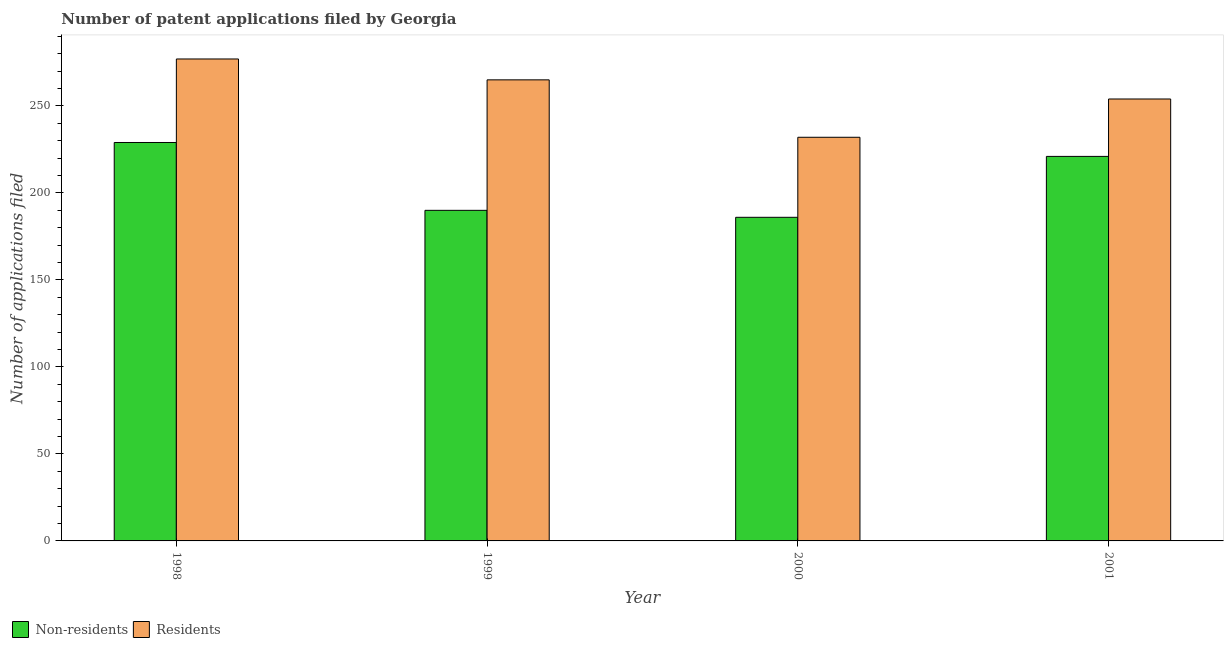How many different coloured bars are there?
Offer a terse response. 2. Are the number of bars per tick equal to the number of legend labels?
Your answer should be very brief. Yes. What is the number of patent applications by residents in 1998?
Your response must be concise. 277. Across all years, what is the maximum number of patent applications by residents?
Your answer should be compact. 277. Across all years, what is the minimum number of patent applications by residents?
Offer a terse response. 232. What is the total number of patent applications by residents in the graph?
Offer a terse response. 1028. What is the difference between the number of patent applications by residents in 1999 and that in 2001?
Provide a short and direct response. 11. What is the difference between the number of patent applications by residents in 1999 and the number of patent applications by non residents in 1998?
Make the answer very short. -12. What is the average number of patent applications by non residents per year?
Offer a very short reply. 206.5. In the year 2001, what is the difference between the number of patent applications by residents and number of patent applications by non residents?
Give a very brief answer. 0. In how many years, is the number of patent applications by non residents greater than 170?
Your response must be concise. 4. What is the ratio of the number of patent applications by non residents in 2000 to that in 2001?
Your response must be concise. 0.84. Is the number of patent applications by residents in 1998 less than that in 2001?
Provide a short and direct response. No. Is the difference between the number of patent applications by non residents in 1998 and 2001 greater than the difference between the number of patent applications by residents in 1998 and 2001?
Keep it short and to the point. No. What is the difference between the highest and the lowest number of patent applications by residents?
Give a very brief answer. 45. What does the 1st bar from the left in 2000 represents?
Your answer should be very brief. Non-residents. What does the 2nd bar from the right in 2000 represents?
Provide a succinct answer. Non-residents. How many years are there in the graph?
Offer a terse response. 4. What is the difference between two consecutive major ticks on the Y-axis?
Your answer should be very brief. 50. Are the values on the major ticks of Y-axis written in scientific E-notation?
Keep it short and to the point. No. Where does the legend appear in the graph?
Your response must be concise. Bottom left. How many legend labels are there?
Keep it short and to the point. 2. What is the title of the graph?
Give a very brief answer. Number of patent applications filed by Georgia. Does "Study and work" appear as one of the legend labels in the graph?
Your response must be concise. No. What is the label or title of the X-axis?
Offer a terse response. Year. What is the label or title of the Y-axis?
Provide a short and direct response. Number of applications filed. What is the Number of applications filed in Non-residents in 1998?
Keep it short and to the point. 229. What is the Number of applications filed of Residents in 1998?
Your response must be concise. 277. What is the Number of applications filed in Non-residents in 1999?
Offer a terse response. 190. What is the Number of applications filed of Residents in 1999?
Give a very brief answer. 265. What is the Number of applications filed in Non-residents in 2000?
Your answer should be very brief. 186. What is the Number of applications filed of Residents in 2000?
Make the answer very short. 232. What is the Number of applications filed of Non-residents in 2001?
Keep it short and to the point. 221. What is the Number of applications filed of Residents in 2001?
Offer a very short reply. 254. Across all years, what is the maximum Number of applications filed in Non-residents?
Your answer should be very brief. 229. Across all years, what is the maximum Number of applications filed of Residents?
Provide a succinct answer. 277. Across all years, what is the minimum Number of applications filed in Non-residents?
Your response must be concise. 186. Across all years, what is the minimum Number of applications filed of Residents?
Provide a short and direct response. 232. What is the total Number of applications filed of Non-residents in the graph?
Make the answer very short. 826. What is the total Number of applications filed of Residents in the graph?
Ensure brevity in your answer.  1028. What is the difference between the Number of applications filed of Residents in 1998 and that in 1999?
Offer a very short reply. 12. What is the difference between the Number of applications filed in Non-residents in 1998 and that in 2000?
Your response must be concise. 43. What is the difference between the Number of applications filed in Non-residents in 1999 and that in 2000?
Offer a terse response. 4. What is the difference between the Number of applications filed in Non-residents in 1999 and that in 2001?
Your answer should be compact. -31. What is the difference between the Number of applications filed in Residents in 1999 and that in 2001?
Offer a terse response. 11. What is the difference between the Number of applications filed of Non-residents in 2000 and that in 2001?
Your answer should be compact. -35. What is the difference between the Number of applications filed in Residents in 2000 and that in 2001?
Give a very brief answer. -22. What is the difference between the Number of applications filed in Non-residents in 1998 and the Number of applications filed in Residents in 1999?
Offer a very short reply. -36. What is the difference between the Number of applications filed in Non-residents in 1998 and the Number of applications filed in Residents in 2000?
Ensure brevity in your answer.  -3. What is the difference between the Number of applications filed in Non-residents in 1999 and the Number of applications filed in Residents in 2000?
Keep it short and to the point. -42. What is the difference between the Number of applications filed in Non-residents in 1999 and the Number of applications filed in Residents in 2001?
Give a very brief answer. -64. What is the difference between the Number of applications filed of Non-residents in 2000 and the Number of applications filed of Residents in 2001?
Give a very brief answer. -68. What is the average Number of applications filed of Non-residents per year?
Offer a very short reply. 206.5. What is the average Number of applications filed in Residents per year?
Make the answer very short. 257. In the year 1998, what is the difference between the Number of applications filed in Non-residents and Number of applications filed in Residents?
Your response must be concise. -48. In the year 1999, what is the difference between the Number of applications filed of Non-residents and Number of applications filed of Residents?
Your response must be concise. -75. In the year 2000, what is the difference between the Number of applications filed of Non-residents and Number of applications filed of Residents?
Your answer should be compact. -46. In the year 2001, what is the difference between the Number of applications filed in Non-residents and Number of applications filed in Residents?
Make the answer very short. -33. What is the ratio of the Number of applications filed in Non-residents in 1998 to that in 1999?
Your response must be concise. 1.21. What is the ratio of the Number of applications filed in Residents in 1998 to that in 1999?
Provide a short and direct response. 1.05. What is the ratio of the Number of applications filed of Non-residents in 1998 to that in 2000?
Offer a terse response. 1.23. What is the ratio of the Number of applications filed in Residents in 1998 to that in 2000?
Provide a short and direct response. 1.19. What is the ratio of the Number of applications filed in Non-residents in 1998 to that in 2001?
Keep it short and to the point. 1.04. What is the ratio of the Number of applications filed in Residents in 1998 to that in 2001?
Make the answer very short. 1.09. What is the ratio of the Number of applications filed of Non-residents in 1999 to that in 2000?
Keep it short and to the point. 1.02. What is the ratio of the Number of applications filed in Residents in 1999 to that in 2000?
Ensure brevity in your answer.  1.14. What is the ratio of the Number of applications filed of Non-residents in 1999 to that in 2001?
Offer a very short reply. 0.86. What is the ratio of the Number of applications filed in Residents in 1999 to that in 2001?
Provide a short and direct response. 1.04. What is the ratio of the Number of applications filed in Non-residents in 2000 to that in 2001?
Your answer should be very brief. 0.84. What is the ratio of the Number of applications filed of Residents in 2000 to that in 2001?
Provide a succinct answer. 0.91. What is the difference between the highest and the second highest Number of applications filed of Non-residents?
Keep it short and to the point. 8. What is the difference between the highest and the lowest Number of applications filed of Non-residents?
Offer a terse response. 43. What is the difference between the highest and the lowest Number of applications filed of Residents?
Your answer should be very brief. 45. 